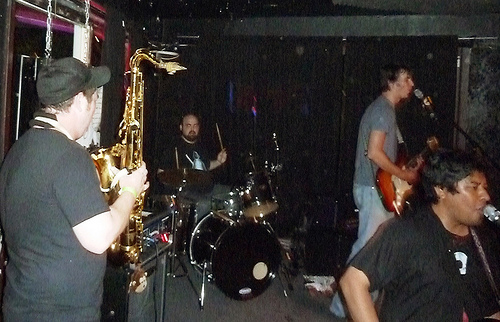<image>
Can you confirm if the man is to the left of the man? No. The man is not to the left of the man. From this viewpoint, they have a different horizontal relationship. 